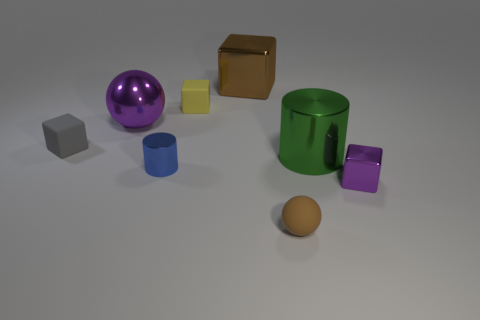Is there any other thing that has the same color as the large cube?
Give a very brief answer. Yes. What shape is the metallic object that is both right of the small yellow thing and behind the gray rubber object?
Offer a terse response. Cube. There is a tiny block to the right of the tiny brown matte thing; is it the same color as the big ball?
Ensure brevity in your answer.  Yes. What is the material of the green thing that is the same size as the brown cube?
Provide a short and direct response. Metal. There is a big thing that is the same color as the tiny rubber sphere; what is its material?
Make the answer very short. Metal. What is the color of the small cylinder that is the same material as the purple sphere?
Keep it short and to the point. Blue. There is a tiny yellow rubber block; how many brown blocks are to the left of it?
Provide a succinct answer. 0. There is a object that is right of the large green metallic object; is it the same color as the ball that is behind the large green metal object?
Your response must be concise. Yes. What color is the small thing that is the same shape as the big green shiny thing?
Your answer should be very brief. Blue. There is a brown object that is behind the large green cylinder; is its shape the same as the large thing that is in front of the big purple thing?
Your answer should be very brief. No. 